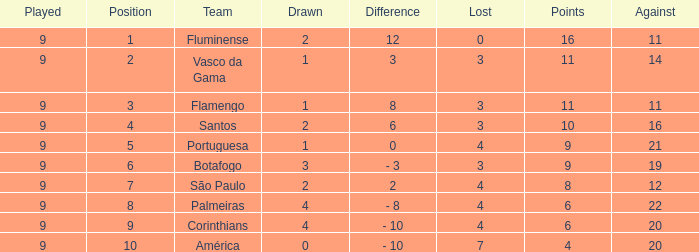Which average Played has a Drawn smaller than 1, and Points larger than 4? None. 